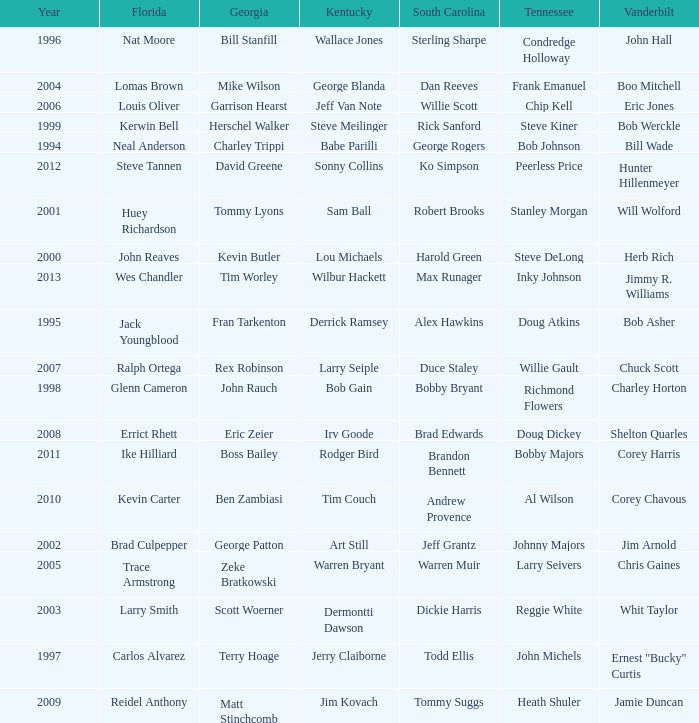What is the total Year of jeff van note ( Kentucky) 2006.0. 